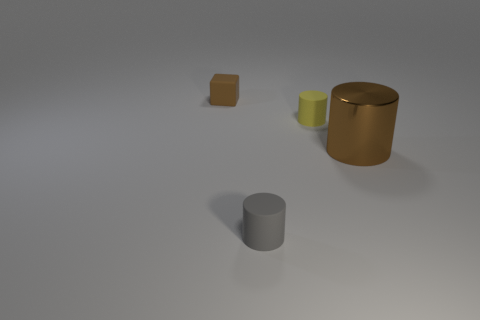Add 2 big brown shiny things. How many objects exist? 6 Subtract all cylinders. How many objects are left? 1 Add 1 yellow rubber cylinders. How many yellow rubber cylinders exist? 2 Subtract 1 yellow cylinders. How many objects are left? 3 Subtract all big gray shiny cubes. Subtract all small gray matte cylinders. How many objects are left? 3 Add 1 small brown cubes. How many small brown cubes are left? 2 